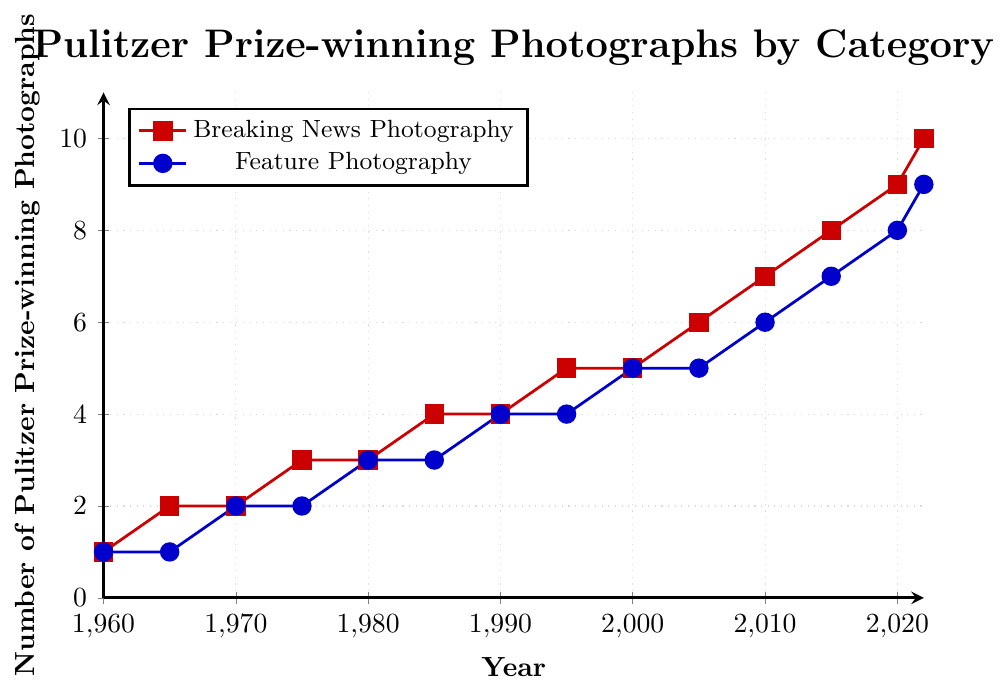What is the total number of Pulitzer Prize-winning photographs for both categories in 2000? We need to look at the data points for 2000 in both categories: Breaking News has 5 and Feature Photography also has 5. Adding them together gives 5+5.
Answer: 10 Which category had more Pulitzer Prize-winning photographs in 1990? We need to compare the data points for 1990: Breaking News has 4 and Feature Photography also has 4. Since they are equal, neither category had more.
Answer: Neither How many more Pulitzer Prize-winning photographs were there in Breaking News Photography in 2022 compared to 1980? We need to calculate the difference between the two values: Breaking News in 2022 is 10 and in 1980 it is 3. The difference is 10 - 3.
Answer: 7 What is the average number of Pulitzer Prize-winning photographs in Feature Photography from 1960 to 1980? We need to add up the values for Feature Photography from 1960 to 1980 and then divide by the number of years. That's (1+1+2+2+3) for the years 1960, 1965, 1970, 1975, and 1980. So, (1+1+2+2+3) / 5.
Answer: 1.8 Between which years did Breaking News Photography see the greatest increase in the number of Pulitzer Prize-winning photographs? We need to look for the largest difference between consecutive years for Breaking News. Checking the increments: 
1960-1965 (1 to 2, increase by 1)
1965-1970 (2 to 2, no increase)
1970-1975 (2 to 3, increase by 1)
1975-1980 (3 to 3, no increase)
1980-1985 (3 to 4, increase by 1)
1985-1990 (4 to 4, no increase)
1990-1995 (4 to 5, increase by 1)
1995-2000 (5 to 5, no increase)
2000-2005 (5 to 6, increase by 1)
2005-2010 (6 to 7, increase by 1)
2010-2015 (7 to 8, increase by 1)
2015-2020 (8 to 9, increase by 1)
2020-2022 (9 to 10, increase by 1)
The greatest increase happens from 1960 to 1965, or in multiple other places but consistently the same, so equal everywhere.
Answer: 1960-1965 and several others In which year did Feature Photography awards surpass 7 for the first time? We need to look for the first year where the value for Feature Photography exceeds 7. Checking the data, we see that it happens in 2020.
Answer: 2020 